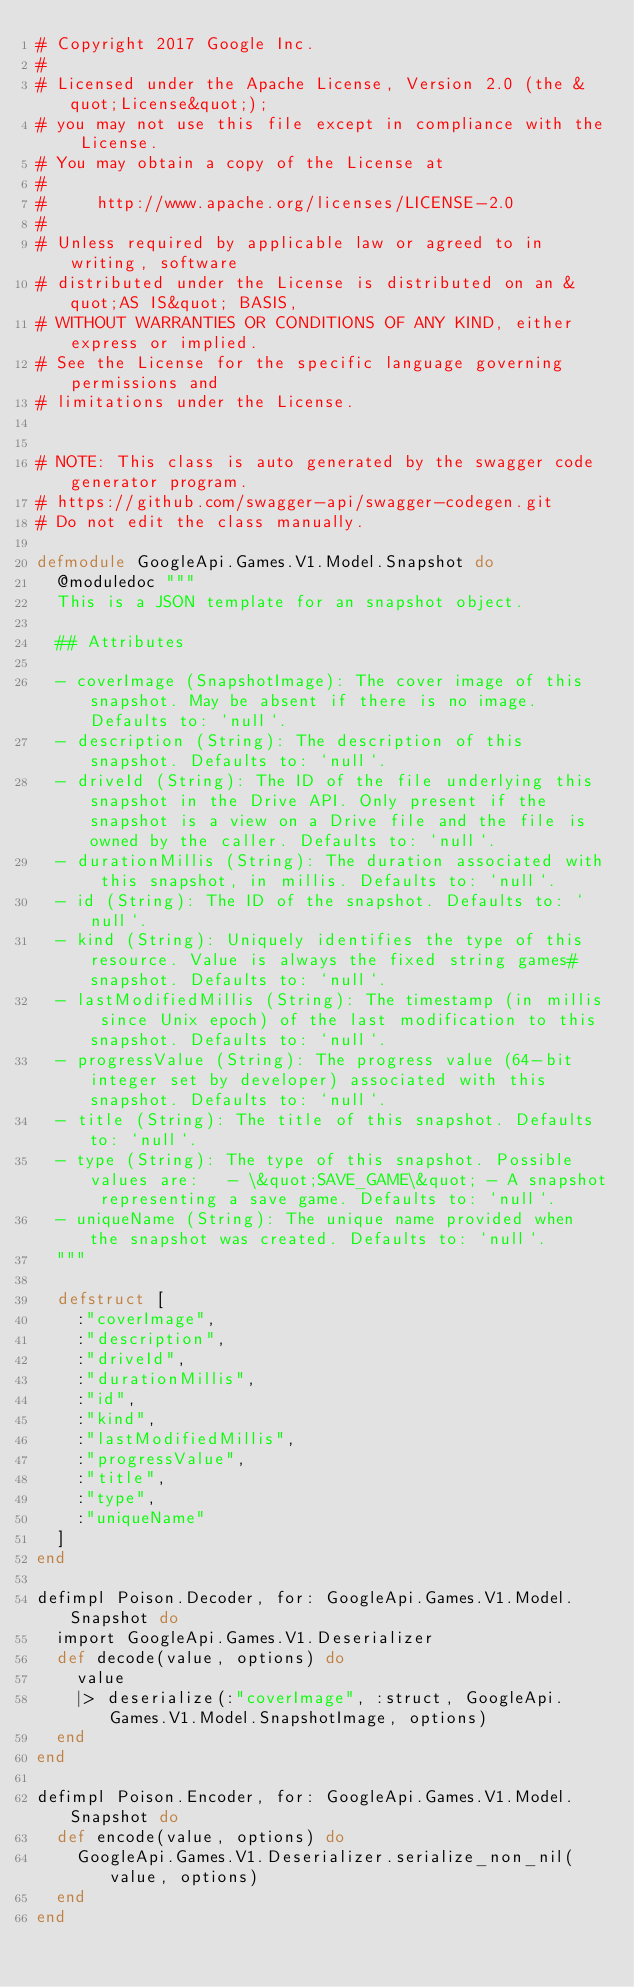<code> <loc_0><loc_0><loc_500><loc_500><_Elixir_># Copyright 2017 Google Inc.
#
# Licensed under the Apache License, Version 2.0 (the &quot;License&quot;);
# you may not use this file except in compliance with the License.
# You may obtain a copy of the License at
#
#     http://www.apache.org/licenses/LICENSE-2.0
#
# Unless required by applicable law or agreed to in writing, software
# distributed under the License is distributed on an &quot;AS IS&quot; BASIS,
# WITHOUT WARRANTIES OR CONDITIONS OF ANY KIND, either express or implied.
# See the License for the specific language governing permissions and
# limitations under the License.


# NOTE: This class is auto generated by the swagger code generator program.
# https://github.com/swagger-api/swagger-codegen.git
# Do not edit the class manually.

defmodule GoogleApi.Games.V1.Model.Snapshot do
  @moduledoc """
  This is a JSON template for an snapshot object.

  ## Attributes

  - coverImage (SnapshotImage): The cover image of this snapshot. May be absent if there is no image. Defaults to: `null`.
  - description (String): The description of this snapshot. Defaults to: `null`.
  - driveId (String): The ID of the file underlying this snapshot in the Drive API. Only present if the snapshot is a view on a Drive file and the file is owned by the caller. Defaults to: `null`.
  - durationMillis (String): The duration associated with this snapshot, in millis. Defaults to: `null`.
  - id (String): The ID of the snapshot. Defaults to: `null`.
  - kind (String): Uniquely identifies the type of this resource. Value is always the fixed string games#snapshot. Defaults to: `null`.
  - lastModifiedMillis (String): The timestamp (in millis since Unix epoch) of the last modification to this snapshot. Defaults to: `null`.
  - progressValue (String): The progress value (64-bit integer set by developer) associated with this snapshot. Defaults to: `null`.
  - title (String): The title of this snapshot. Defaults to: `null`.
  - type (String): The type of this snapshot. Possible values are:   - \&quot;SAVE_GAME\&quot; - A snapshot representing a save game. Defaults to: `null`.
  - uniqueName (String): The unique name provided when the snapshot was created. Defaults to: `null`.
  """

  defstruct [
    :"coverImage",
    :"description",
    :"driveId",
    :"durationMillis",
    :"id",
    :"kind",
    :"lastModifiedMillis",
    :"progressValue",
    :"title",
    :"type",
    :"uniqueName"
  ]
end

defimpl Poison.Decoder, for: GoogleApi.Games.V1.Model.Snapshot do
  import GoogleApi.Games.V1.Deserializer
  def decode(value, options) do
    value
    |> deserialize(:"coverImage", :struct, GoogleApi.Games.V1.Model.SnapshotImage, options)
  end
end

defimpl Poison.Encoder, for: GoogleApi.Games.V1.Model.Snapshot do
  def encode(value, options) do
    GoogleApi.Games.V1.Deserializer.serialize_non_nil(value, options)
  end
end

</code> 